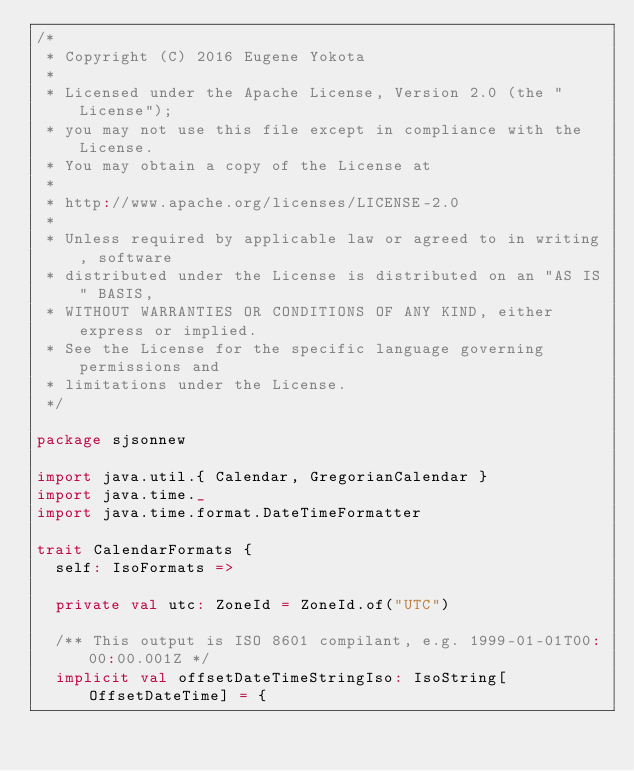<code> <loc_0><loc_0><loc_500><loc_500><_Scala_>/*
 * Copyright (C) 2016 Eugene Yokota
 *
 * Licensed under the Apache License, Version 2.0 (the "License");
 * you may not use this file except in compliance with the License.
 * You may obtain a copy of the License at
 *
 * http://www.apache.org/licenses/LICENSE-2.0
 *
 * Unless required by applicable law or agreed to in writing, software
 * distributed under the License is distributed on an "AS IS" BASIS,
 * WITHOUT WARRANTIES OR CONDITIONS OF ANY KIND, either express or implied.
 * See the License for the specific language governing permissions and
 * limitations under the License.
 */

package sjsonnew

import java.util.{ Calendar, GregorianCalendar }
import java.time._
import java.time.format.DateTimeFormatter

trait CalendarFormats {
  self: IsoFormats =>

  private val utc: ZoneId = ZoneId.of("UTC")

  /** This output is ISO 8601 compilant, e.g. 1999-01-01T00:00:00.001Z */
  implicit val offsetDateTimeStringIso: IsoString[OffsetDateTime] = {</code> 